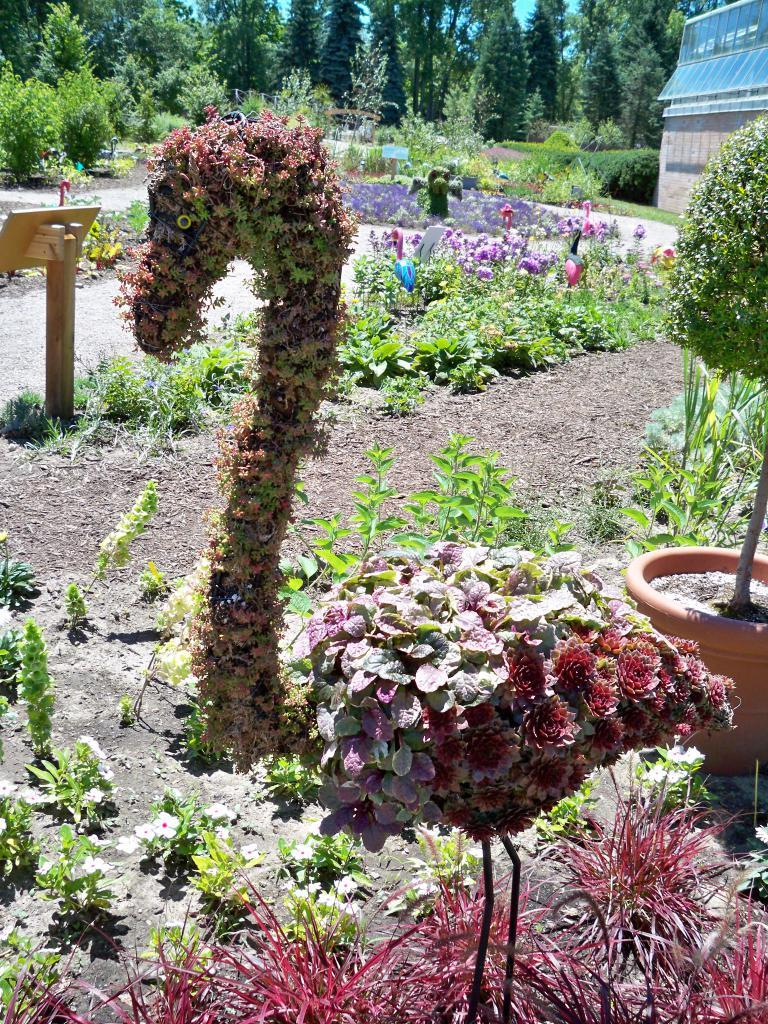What types of vegetation can be seen in the image? There are flowers and plants in the image. Where is the house located in the image? The house is at the right top of the image. What can be seen in the background of the image? There are trees in the background of the image. What type of skirt is being worn by the tree in the image? There are no skirts or people present in the image, as it features flowers, plants, a house, and trees. 